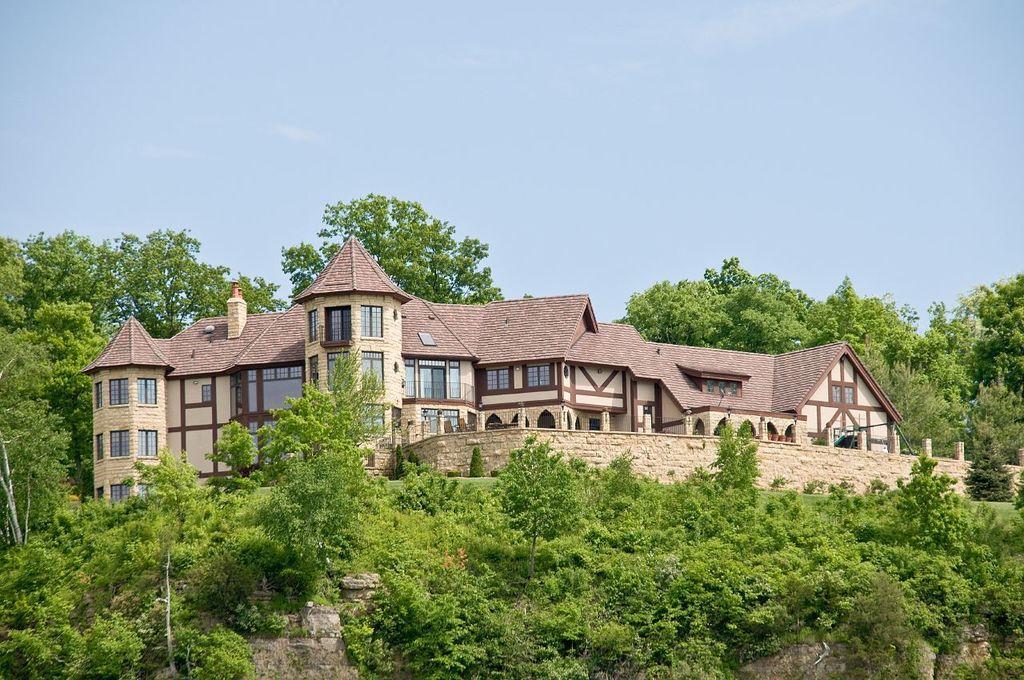Could you give a brief overview of what you see in this image? In this image, I can see trees and a building with windows. In the background, there is the sky. 